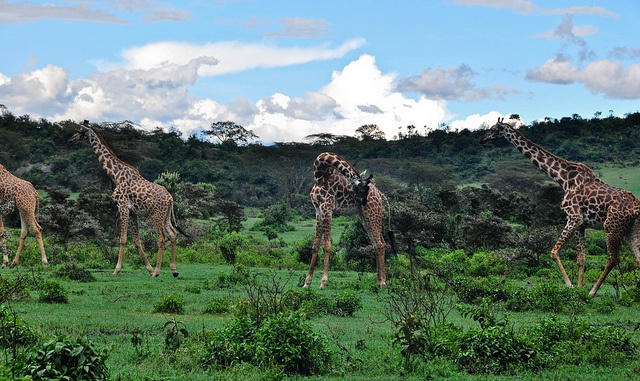Describe the objects in this image and their specific colors. I can see giraffe in lavender, black, gray, and maroon tones, giraffe in lavender, gray, black, and darkgray tones, giraffe in lavender, black, gray, maroon, and darkgray tones, and giraffe in lavender, gray, and tan tones in this image. 